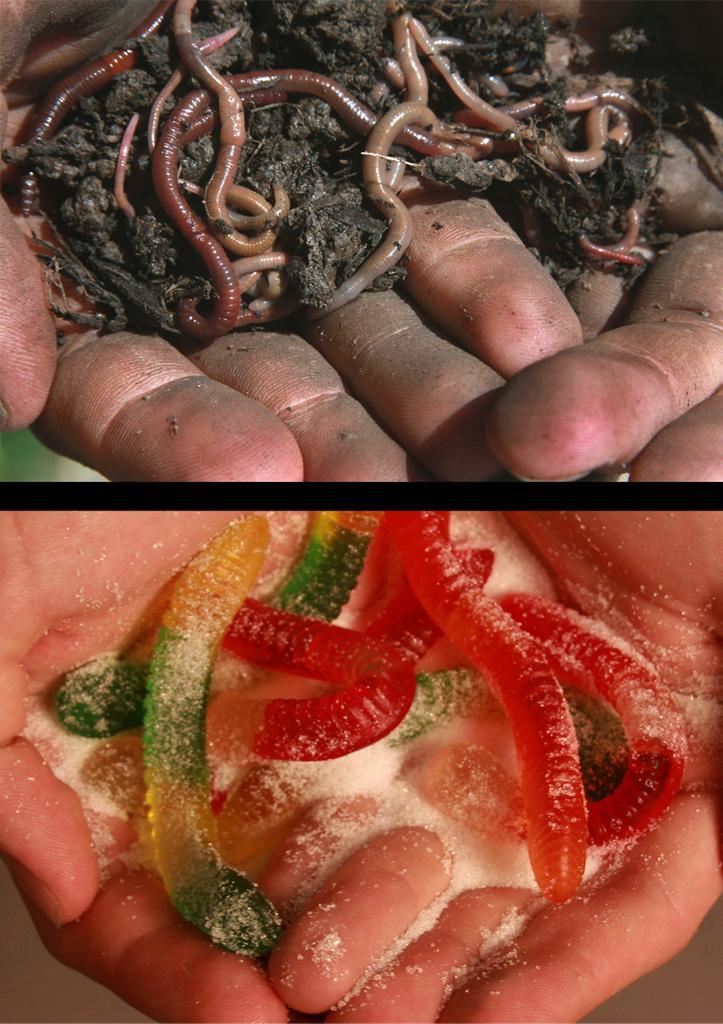Can you describe this image briefly? I see this is a collage image and I see persons hands on which I see few colorful jellies over here and I see the white color powder and in this image I see the black mud and insects which are of brown and cream in color. 